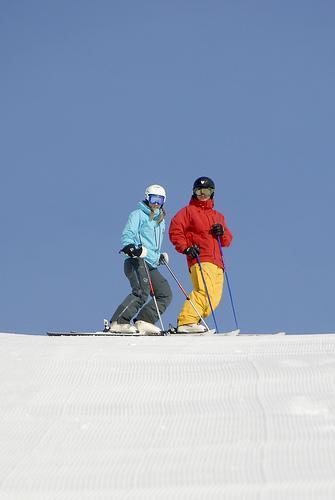How many people are there?
Give a very brief answer. 2. 